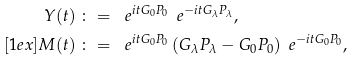Convert formula to latex. <formula><loc_0><loc_0><loc_500><loc_500>Y ( t ) & \ \colon = \ \ e ^ { i t G _ { 0 } P _ { 0 } } \, \ e ^ { - i t G _ { \lambda } P _ { \lambda } } , \\ [ 1 e x ] M ( t ) & \ \colon = \ \ e ^ { i t G _ { 0 } P _ { 0 } } \left ( G _ { \lambda } P _ { \lambda } - G _ { 0 } P _ { 0 } \right ) \ e ^ { - i t G _ { 0 } P _ { 0 } } ,</formula> 